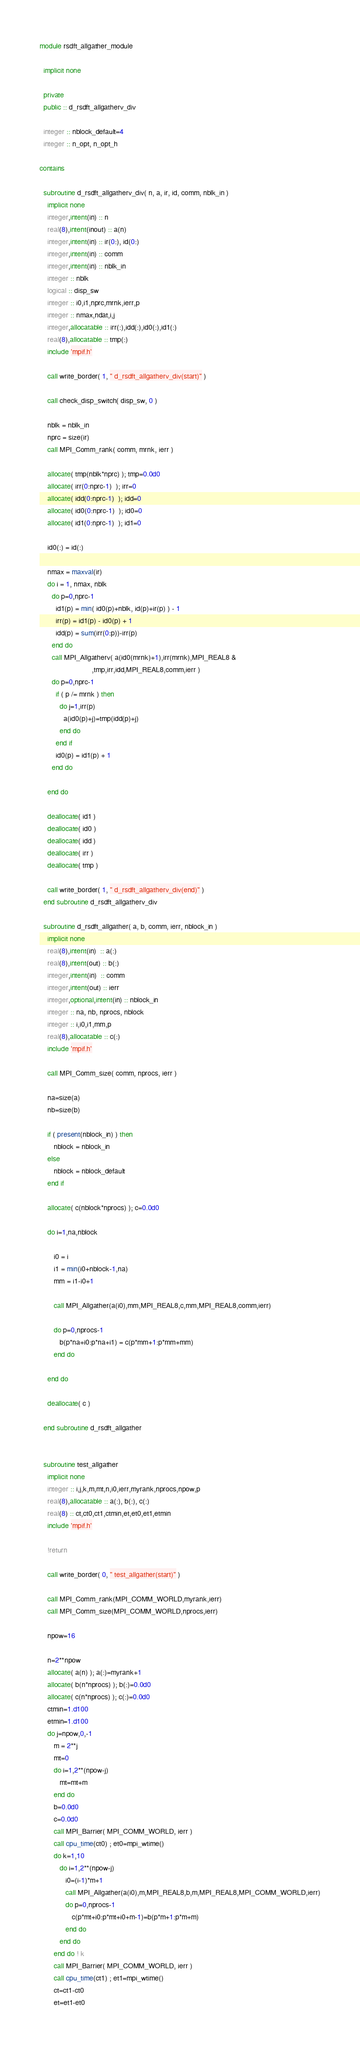Convert code to text. <code><loc_0><loc_0><loc_500><loc_500><_FORTRAN_>module rsdft_allgather_module

  implicit none

  private
  public :: d_rsdft_allgatherv_div

  integer :: nblock_default=4
  integer :: n_opt, n_opt_h

contains

  subroutine d_rsdft_allgatherv_div( n, a, ir, id, comm, nblk_in )
    implicit none
    integer,intent(in) :: n
    real(8),intent(inout) :: a(n)
    integer,intent(in) :: ir(0:), id(0:)
    integer,intent(in) :: comm
    integer,intent(in) :: nblk_in
    integer :: nblk
    logical :: disp_sw
    integer :: i0,i1,nprc,mrnk,ierr,p
    integer :: nmax,ndat,i,j
    integer,allocatable :: irr(:),idd(:),id0(:),id1(:)
    real(8),allocatable :: tmp(:)
    include 'mpif.h'

    call write_border( 1, " d_rsdft_allgatherv_div(start)" )

    call check_disp_switch( disp_sw, 0 )

    nblk = nblk_in
    nprc = size(ir)
    call MPI_Comm_rank( comm, mrnk, ierr )

    allocate( tmp(nblk*nprc) ); tmp=0.0d0
    allocate( irr(0:nprc-1)  ); irr=0
    allocate( idd(0:nprc-1)  ); idd=0
    allocate( id0(0:nprc-1)  ); id0=0
    allocate( id1(0:nprc-1)  ); id1=0

    id0(:) = id(:)

    nmax = maxval(ir)
    do i = 1, nmax, nblk
      do p=0,nprc-1
        id1(p) = min( id0(p)+nblk, id(p)+ir(p) ) - 1
        irr(p) = id1(p) - id0(p) + 1
        idd(p) = sum(irr(0:p))-irr(p)
      end do
      call MPI_Allgatherv( a(id0(mrnk)+1),irr(mrnk),MPI_REAL8 &
                          ,tmp,irr,idd,MPI_REAL8,comm,ierr )
      do p=0,nprc-1
        if ( p /= mrnk ) then
          do j=1,irr(p)
            a(id0(p)+j)=tmp(idd(p)+j)
          end do
        end if        
        id0(p) = id1(p) + 1
      end do

    end do

    deallocate( id1 )
    deallocate( id0 )
    deallocate( idd )
    deallocate( irr )
    deallocate( tmp )

    call write_border( 1, " d_rsdft_allgatherv_div(end)" )
  end subroutine d_rsdft_allgatherv_div

  subroutine d_rsdft_allgather( a, b, comm, ierr, nblock_in )
    implicit none
    real(8),intent(in)  :: a(:)
    real(8),intent(out) :: b(:)
    integer,intent(in)  :: comm
    integer,intent(out) :: ierr
    integer,optional,intent(in) :: nblock_in
    integer :: na, nb, nprocs, nblock
    integer :: i,i0,i1,mm,p
    real(8),allocatable :: c(:)
    include 'mpif.h'

    call MPI_Comm_size( comm, nprocs, ierr )

    na=size(a)
    nb=size(b)

    if ( present(nblock_in) ) then
       nblock = nblock_in
    else
       nblock = nblock_default
    end if

    allocate( c(nblock*nprocs) ); c=0.0d0

    do i=1,na,nblock

       i0 = i
       i1 = min(i0+nblock-1,na)
       mm = i1-i0+1

       call MPI_Allgather(a(i0),mm,MPI_REAL8,c,mm,MPI_REAL8,comm,ierr)

       do p=0,nprocs-1
          b(p*na+i0:p*na+i1) = c(p*mm+1:p*mm+mm)
       end do

    end do

    deallocate( c )

  end subroutine d_rsdft_allgather


  subroutine test_allgather
    implicit none
    integer :: i,j,k,m,mt,n,i0,ierr,myrank,nprocs,npow,p
    real(8),allocatable :: a(:), b(:), c(:)
    real(8) :: ct,ct0,ct1,ctmin,et,et0,et1,etmin
    include 'mpif.h'

    !return

    call write_border( 0, " test_allgather(start)" )

    call MPI_Comm_rank(MPI_COMM_WORLD,myrank,ierr)
    call MPI_Comm_size(MPI_COMM_WORLD,nprocs,ierr)

    npow=16

    n=2**npow
    allocate( a(n) ); a(:)=myrank+1
    allocate( b(n*nprocs) ); b(:)=0.0d0
    allocate( c(n*nprocs) ); c(:)=0.0d0
    ctmin=1.d100
    etmin=1.d100
    do j=npow,0,-1
       m = 2**j
       mt=0
       do i=1,2**(npow-j)
          mt=mt+m
       end do
       b=0.0d0
       c=0.0d0
       call MPI_Barrier( MPI_COMM_WORLD, ierr )
       call cpu_time(ct0) ; et0=mpi_wtime()
       do k=1,10
          do i=1,2**(npow-j)
             i0=(i-1)*m+1
             call MPI_Allgather(a(i0),m,MPI_REAL8,b,m,MPI_REAL8,MPI_COMM_WORLD,ierr)
             do p=0,nprocs-1
                c(p*mt+i0:p*mt+i0+m-1)=b(p*m+1:p*m+m)
             end do
          end do
       end do ! k
       call MPI_Barrier( MPI_COMM_WORLD, ierr )
       call cpu_time(ct1) ; et1=mpi_wtime()
       ct=ct1-ct0
       et=et1-et0</code> 